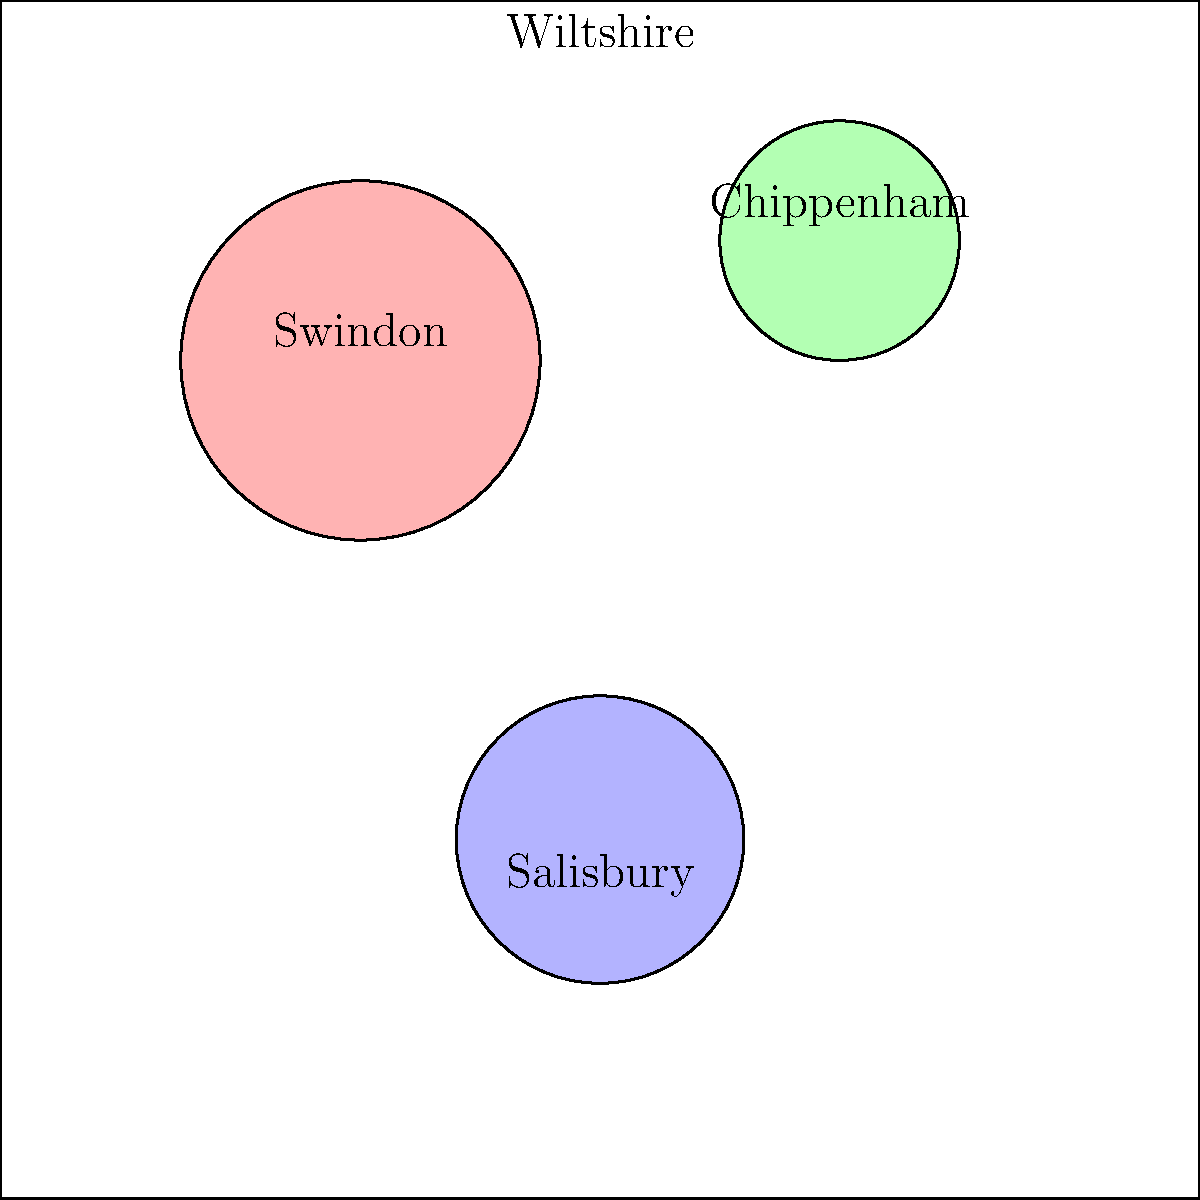Based on the map of Wiltshire, which town appears to have the largest area of activist activity, and what factors might contribute to this? To answer this question, we need to analyze the map and consider the following steps:

1. Observe the highlighted areas: The map shows three highlighted regions representing activist activity in Wiltshire.

2. Compare the sizes of the highlighted areas:
   - Swindon (top left): Largest highlighted area
   - Chippenham (top right): Smallest highlighted area
   - Salisbury (bottom center): Medium-sized highlighted area

3. Identify the largest area: Swindon has the largest highlighted region, indicating the most extensive activist activity.

4. Consider factors that might contribute to Swindon's larger activist base:
   a) Population: Swindon is the largest town in Wiltshire, with a population of over 200,000.
   b) Urban environment: More densely populated areas often have more social issues to address.
   c) Economic factors: Swindon has a diverse economy, which may lead to various activist causes.
   d) Transportation hub: As a major railway junction, Swindon may attract more diverse groups.
   e) Educational institutions: The presence of colleges and universities can foster activist movements.

5. Conclusion: Swindon appears to have the largest area of activist activity, likely due to its larger population, urban environment, and socio-economic factors.
Answer: Swindon; largest population and urban environment 